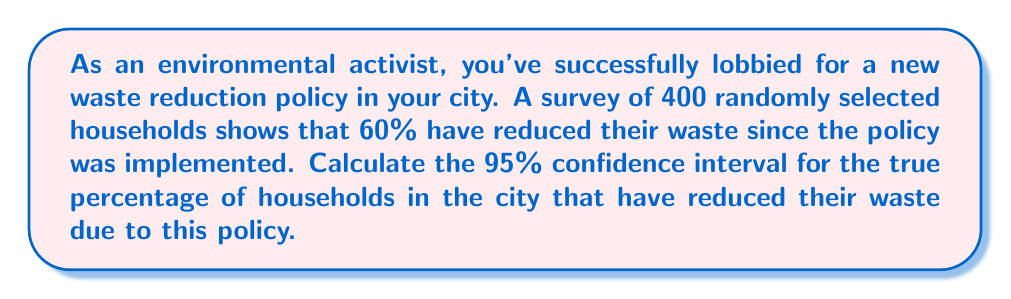Can you solve this math problem? To calculate the confidence interval, we'll follow these steps:

1) First, identify the key components:
   - Sample proportion (p̂) = 60% = 0.60
   - Sample size (n) = 400
   - Confidence level = 95% (z-score = 1.96)

2) Calculate the standard error (SE) of the proportion:
   $$ SE = \sqrt{\frac{p̂(1-p̂)}{n}} = \sqrt{\frac{0.60(1-0.60)}{400}} = 0.0245 $$

3) Calculate the margin of error (ME):
   $$ ME = z \times SE = 1.96 \times 0.0245 = 0.0480 $$

4) Calculate the confidence interval:
   Lower bound: $$ p̂ - ME = 0.60 - 0.0480 = 0.5520 $$
   Upper bound: $$ p̂ + ME = 0.60 + 0.0480 = 0.6480 $$

5) Convert to percentages:
   Lower bound: 55.20%
   Upper bound: 64.80%

Therefore, we can be 95% confident that the true percentage of households in the city that have reduced their waste due to the new policy is between 55.20% and 64.80%.
Answer: (55.20%, 64.80%) 